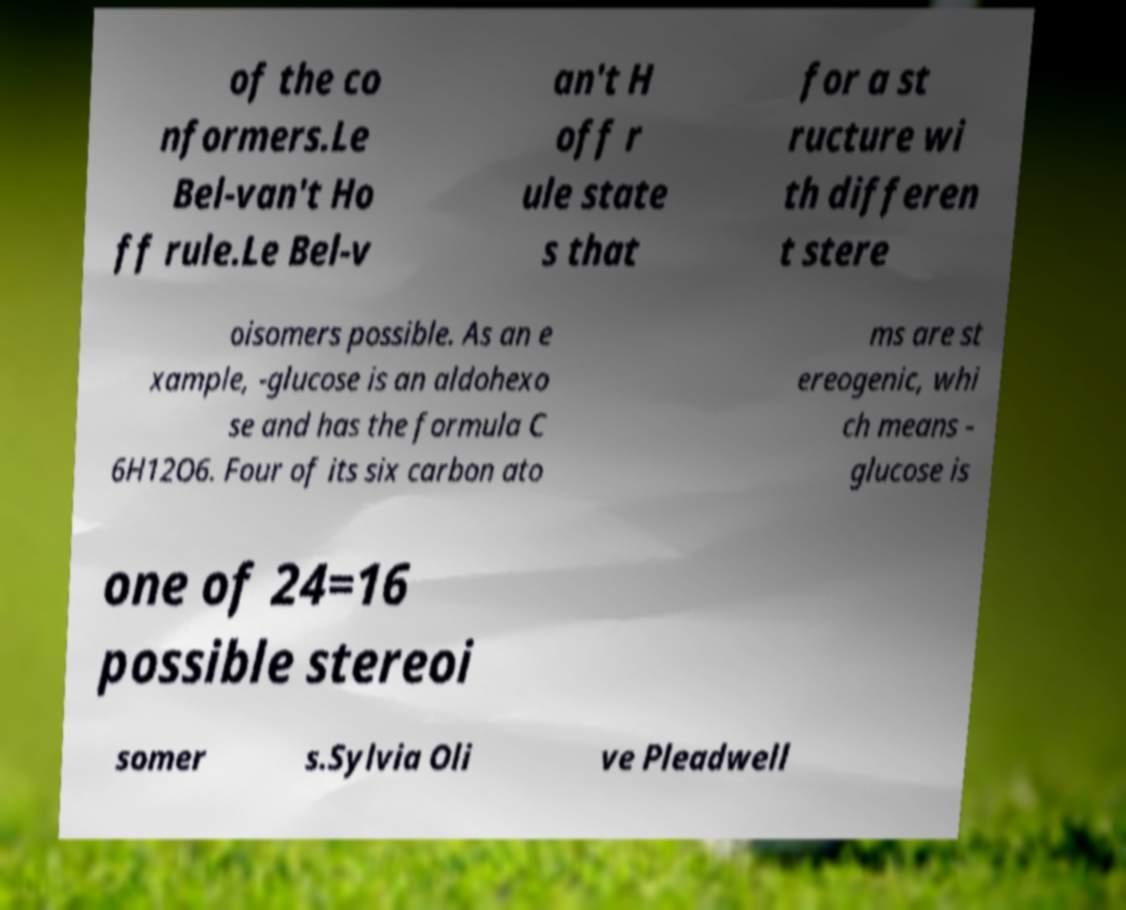Could you assist in decoding the text presented in this image and type it out clearly? of the co nformers.Le Bel-van't Ho ff rule.Le Bel-v an't H off r ule state s that for a st ructure wi th differen t stere oisomers possible. As an e xample, -glucose is an aldohexo se and has the formula C 6H12O6. Four of its six carbon ato ms are st ereogenic, whi ch means - glucose is one of 24=16 possible stereoi somer s.Sylvia Oli ve Pleadwell 